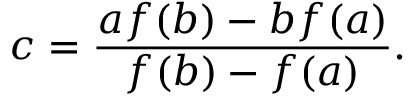Convert formula to latex. <formula><loc_0><loc_0><loc_500><loc_500>c = { \frac { a f ( b ) - b f ( a ) } { f ( b ) - f ( a ) } } .</formula> 